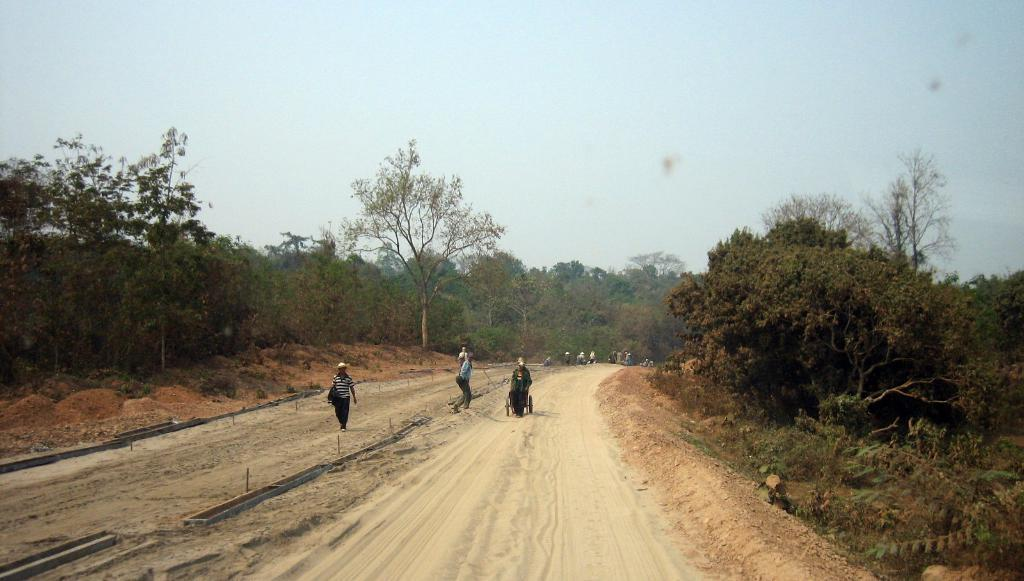What are the people in the image doing? There are many people walking on the road in the image. What is at the bottom of the image? There is sand at the bottom of the image. What can be seen on the sides of the image? There are many trees on the left and right sides of the image. What is visible at the top of the image? The sky is visible at the top of the image. What type of birds can be seen flying in the image? There are no birds visible in the image; it only shows people walking on the road, sand, trees, and the sky. 